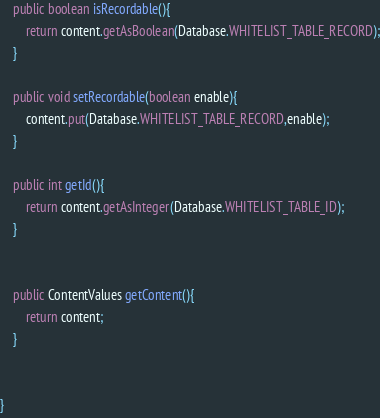<code> <loc_0><loc_0><loc_500><loc_500><_Java_>    public boolean isRecordable(){
        return content.getAsBoolean(Database.WHITELIST_TABLE_RECORD);
    }

    public void setRecordable(boolean enable){
        content.put(Database.WHITELIST_TABLE_RECORD,enable);
    }

    public int getId(){
        return content.getAsInteger(Database.WHITELIST_TABLE_ID);
    }


    public ContentValues getContent(){
        return content;
    }


}
</code> 